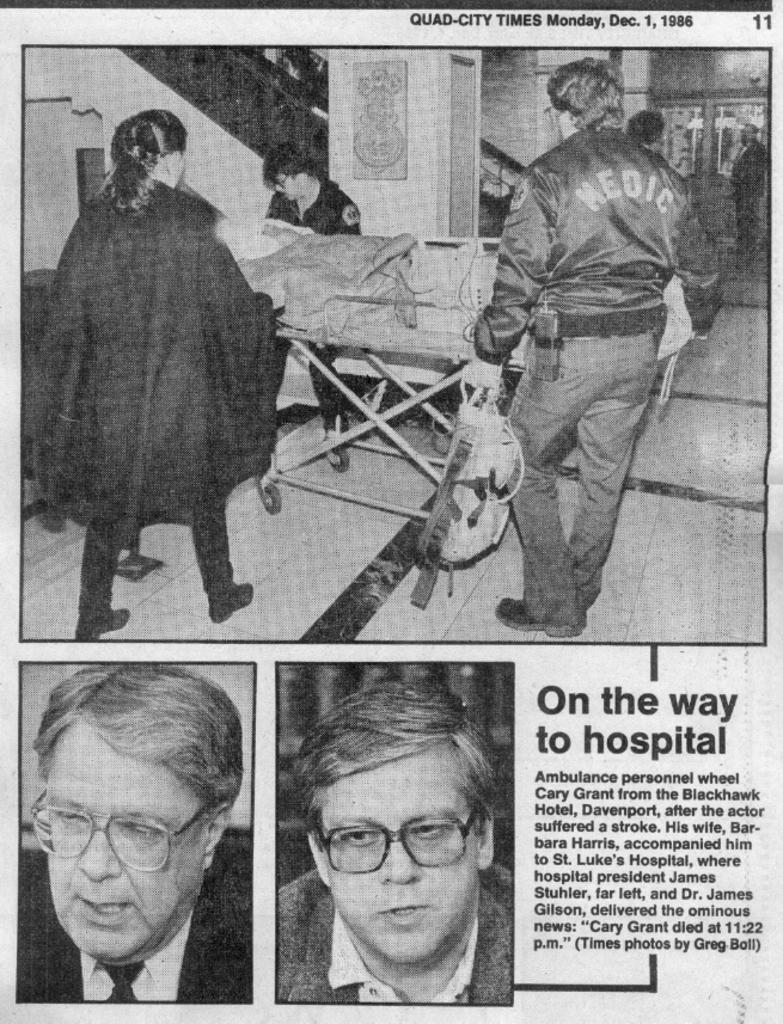<image>
Describe the image concisely. A news photo from the Dec. 1, 1986 edition of the Quad-City Times 